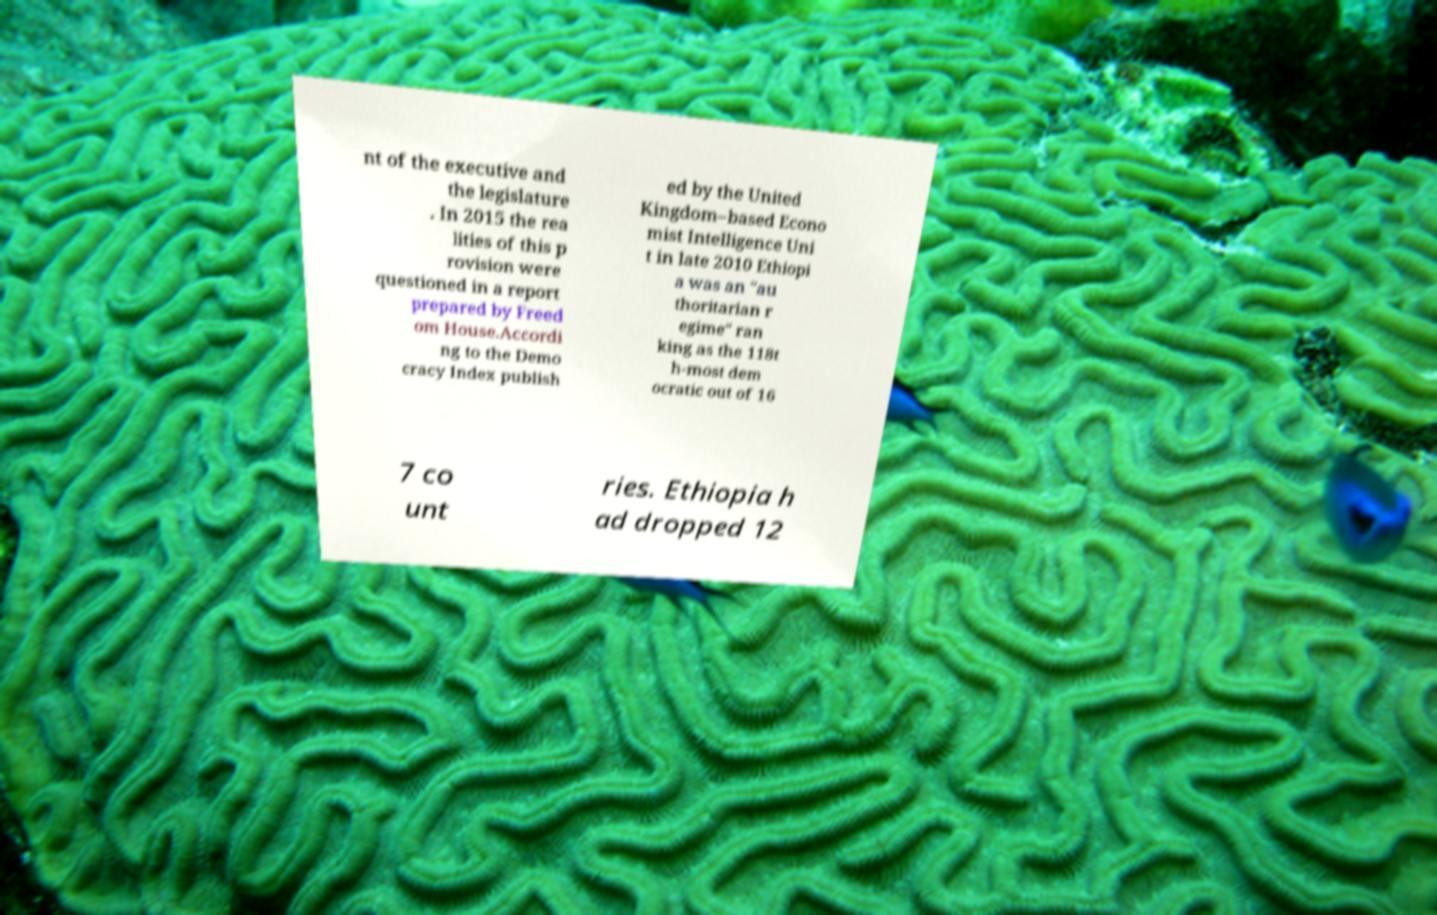Could you assist in decoding the text presented in this image and type it out clearly? nt of the executive and the legislature . In 2015 the rea lities of this p rovision were questioned in a report prepared by Freed om House.Accordi ng to the Demo cracy Index publish ed by the United Kingdom–based Econo mist Intelligence Uni t in late 2010 Ethiopi a was an "au thoritarian r egime" ran king as the 118t h-most dem ocratic out of 16 7 co unt ries. Ethiopia h ad dropped 12 